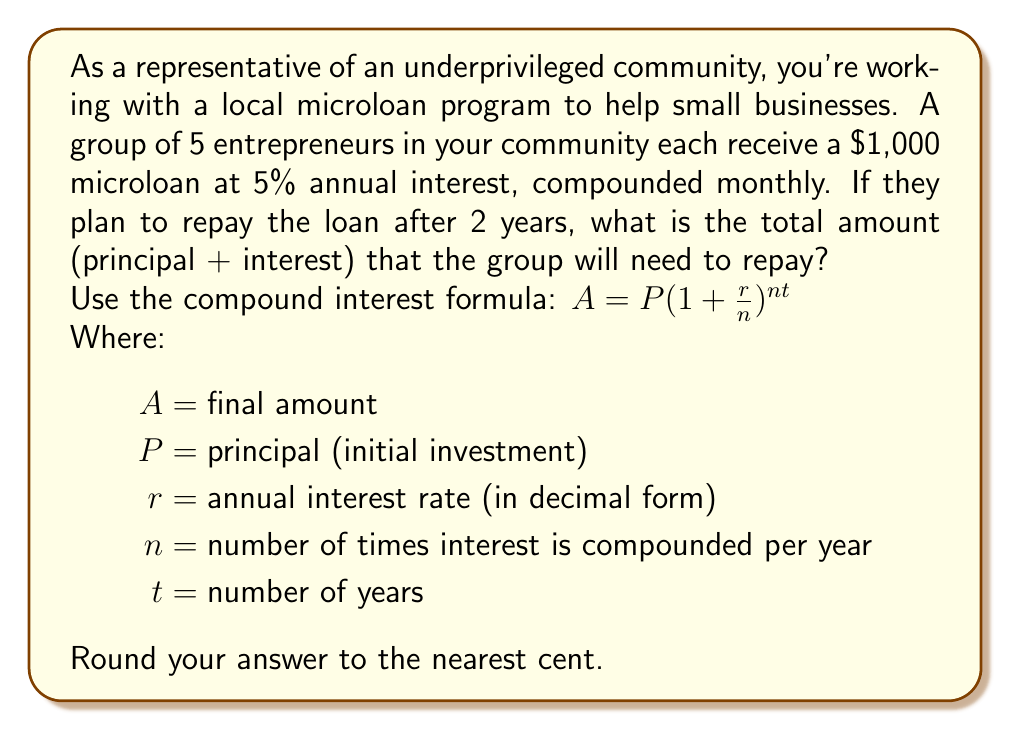Can you solve this math problem? Let's break this down step-by-step:

1) First, let's identify our variables:
   $P = 1000$ (for each entrepreneur)
   $r = 0.05$ (5% annual interest rate)
   $n = 12$ (compounded monthly, so 12 times per year)
   $t = 2$ (2 years)

2) Now, let's plug these into our formula:

   $A = 1000(1 + \frac{0.05}{12})^{12 * 2}$

3) Simplify inside the parentheses:

   $A = 1000(1 + 0.004167)^{24}$

4) Calculate the exponent:

   $A = 1000(1.004167)^{24}$

5) Use a calculator to compute this:

   $A = 1000 * 1.105156 = 1105.156$

6) This is the amount each entrepreneur will need to repay. Since there are 5 entrepreneurs, we multiply by 5:

   $5 * 1105.156 = 5525.78$

Therefore, the group will need to repay a total of $5,525.78.
Answer: $5,525.78 